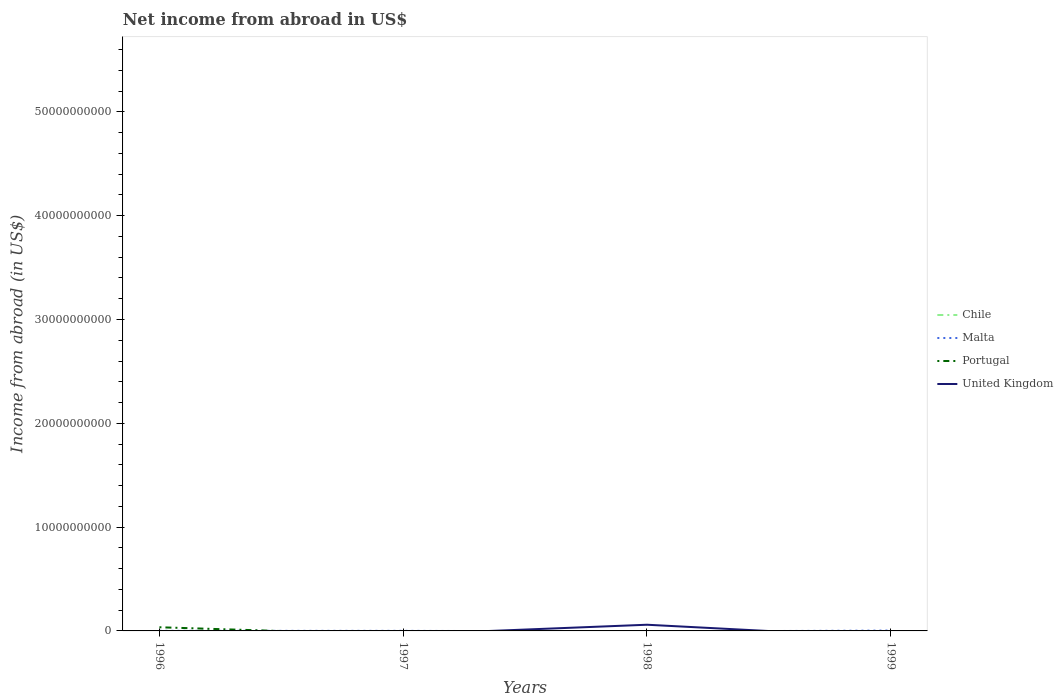Does the line corresponding to Portugal intersect with the line corresponding to Chile?
Provide a succinct answer. No. Is the number of lines equal to the number of legend labels?
Offer a very short reply. No. What is the total net income from abroad in Malta in the graph?
Provide a short and direct response. 1.10e+06. What is the difference between the highest and the second highest net income from abroad in United Kingdom?
Provide a succinct answer. 5.96e+08. What is the difference between the highest and the lowest net income from abroad in Chile?
Provide a short and direct response. 0. How many lines are there?
Offer a terse response. 3. How many years are there in the graph?
Provide a succinct answer. 4. Are the values on the major ticks of Y-axis written in scientific E-notation?
Provide a short and direct response. No. Does the graph contain any zero values?
Offer a terse response. Yes. Where does the legend appear in the graph?
Make the answer very short. Center right. How are the legend labels stacked?
Keep it short and to the point. Vertical. What is the title of the graph?
Provide a succinct answer. Net income from abroad in US$. Does "Tanzania" appear as one of the legend labels in the graph?
Give a very brief answer. No. What is the label or title of the X-axis?
Your answer should be compact. Years. What is the label or title of the Y-axis?
Make the answer very short. Income from abroad (in US$). What is the Income from abroad (in US$) in Chile in 1996?
Your answer should be compact. 0. What is the Income from abroad (in US$) of Malta in 1996?
Provide a short and direct response. 8.70e+06. What is the Income from abroad (in US$) of Portugal in 1996?
Your answer should be very brief. 3.53e+08. What is the Income from abroad (in US$) of United Kingdom in 1996?
Provide a short and direct response. 0. What is the Income from abroad (in US$) in Malta in 1997?
Provide a short and direct response. 7.60e+06. What is the Income from abroad (in US$) of Portugal in 1997?
Ensure brevity in your answer.  0. What is the Income from abroad (in US$) in Malta in 1998?
Keep it short and to the point. 0. What is the Income from abroad (in US$) of United Kingdom in 1998?
Keep it short and to the point. 5.96e+08. What is the Income from abroad (in US$) in Malta in 1999?
Your answer should be very brief. 3.60e+07. What is the Income from abroad (in US$) in United Kingdom in 1999?
Make the answer very short. 0. Across all years, what is the maximum Income from abroad (in US$) of Malta?
Keep it short and to the point. 3.60e+07. Across all years, what is the maximum Income from abroad (in US$) of Portugal?
Your response must be concise. 3.53e+08. Across all years, what is the maximum Income from abroad (in US$) of United Kingdom?
Offer a terse response. 5.96e+08. Across all years, what is the minimum Income from abroad (in US$) of Malta?
Ensure brevity in your answer.  0. Across all years, what is the minimum Income from abroad (in US$) of Portugal?
Provide a succinct answer. 0. Across all years, what is the minimum Income from abroad (in US$) of United Kingdom?
Your answer should be compact. 0. What is the total Income from abroad (in US$) of Chile in the graph?
Offer a terse response. 0. What is the total Income from abroad (in US$) of Malta in the graph?
Make the answer very short. 5.23e+07. What is the total Income from abroad (in US$) in Portugal in the graph?
Give a very brief answer. 3.53e+08. What is the total Income from abroad (in US$) of United Kingdom in the graph?
Provide a succinct answer. 5.96e+08. What is the difference between the Income from abroad (in US$) in Malta in 1996 and that in 1997?
Give a very brief answer. 1.10e+06. What is the difference between the Income from abroad (in US$) of Malta in 1996 and that in 1999?
Provide a short and direct response. -2.73e+07. What is the difference between the Income from abroad (in US$) in Malta in 1997 and that in 1999?
Provide a succinct answer. -2.84e+07. What is the difference between the Income from abroad (in US$) in Malta in 1996 and the Income from abroad (in US$) in United Kingdom in 1998?
Offer a very short reply. -5.87e+08. What is the difference between the Income from abroad (in US$) in Portugal in 1996 and the Income from abroad (in US$) in United Kingdom in 1998?
Your answer should be very brief. -2.43e+08. What is the difference between the Income from abroad (in US$) in Malta in 1997 and the Income from abroad (in US$) in United Kingdom in 1998?
Keep it short and to the point. -5.88e+08. What is the average Income from abroad (in US$) in Malta per year?
Your answer should be very brief. 1.31e+07. What is the average Income from abroad (in US$) in Portugal per year?
Provide a short and direct response. 8.82e+07. What is the average Income from abroad (in US$) of United Kingdom per year?
Offer a terse response. 1.49e+08. In the year 1996, what is the difference between the Income from abroad (in US$) in Malta and Income from abroad (in US$) in Portugal?
Your answer should be compact. -3.44e+08. What is the ratio of the Income from abroad (in US$) in Malta in 1996 to that in 1997?
Your answer should be very brief. 1.14. What is the ratio of the Income from abroad (in US$) in Malta in 1996 to that in 1999?
Your response must be concise. 0.24. What is the ratio of the Income from abroad (in US$) of Malta in 1997 to that in 1999?
Provide a short and direct response. 0.21. What is the difference between the highest and the second highest Income from abroad (in US$) in Malta?
Your answer should be compact. 2.73e+07. What is the difference between the highest and the lowest Income from abroad (in US$) in Malta?
Offer a very short reply. 3.60e+07. What is the difference between the highest and the lowest Income from abroad (in US$) of Portugal?
Give a very brief answer. 3.53e+08. What is the difference between the highest and the lowest Income from abroad (in US$) in United Kingdom?
Provide a short and direct response. 5.96e+08. 